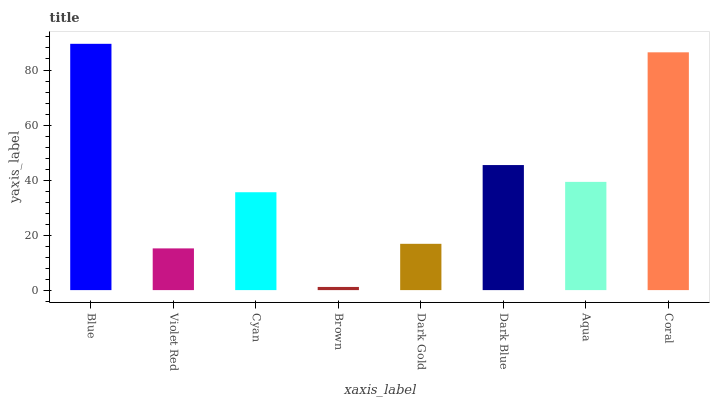Is Violet Red the minimum?
Answer yes or no. No. Is Violet Red the maximum?
Answer yes or no. No. Is Blue greater than Violet Red?
Answer yes or no. Yes. Is Violet Red less than Blue?
Answer yes or no. Yes. Is Violet Red greater than Blue?
Answer yes or no. No. Is Blue less than Violet Red?
Answer yes or no. No. Is Aqua the high median?
Answer yes or no. Yes. Is Cyan the low median?
Answer yes or no. Yes. Is Dark Gold the high median?
Answer yes or no. No. Is Aqua the low median?
Answer yes or no. No. 